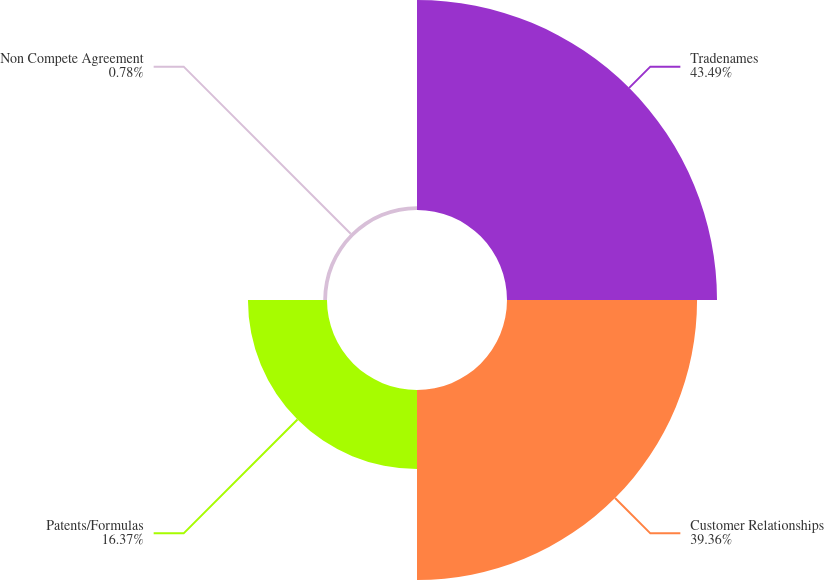<chart> <loc_0><loc_0><loc_500><loc_500><pie_chart><fcel>Tradenames<fcel>Customer Relationships<fcel>Patents/Formulas<fcel>Non Compete Agreement<nl><fcel>43.49%<fcel>39.36%<fcel>16.37%<fcel>0.78%<nl></chart> 